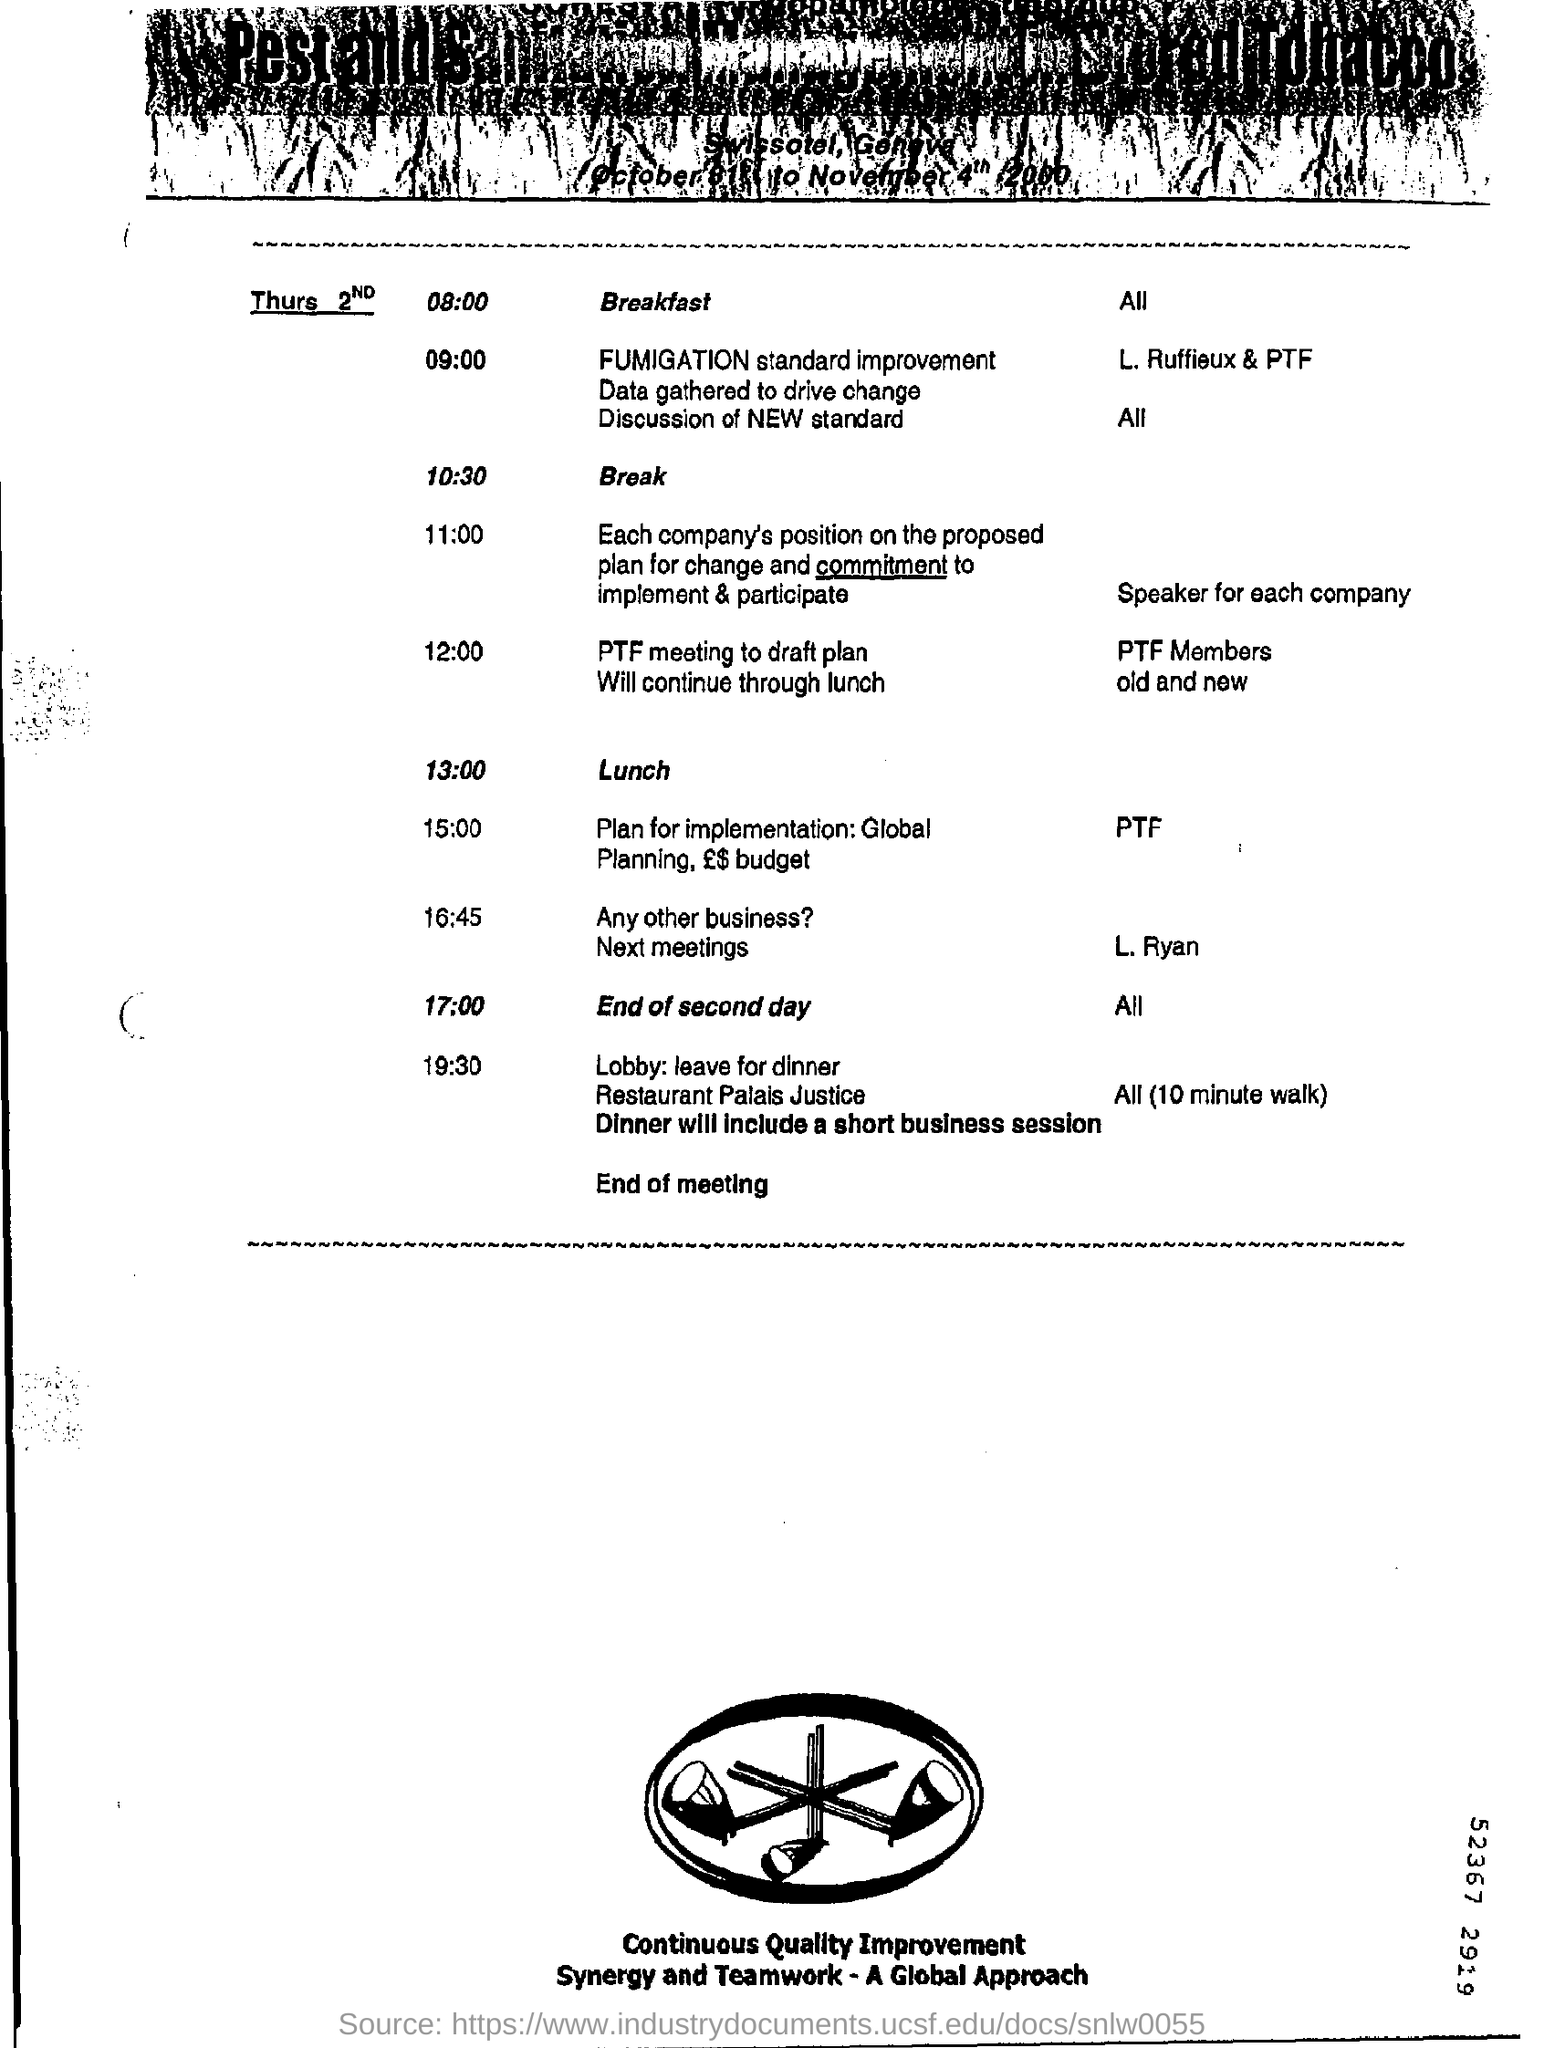Indicate a few pertinent items in this graphic. The second day will end at 17:00. It is scheduled for 10:30. The lunch will take place at 13:00. 